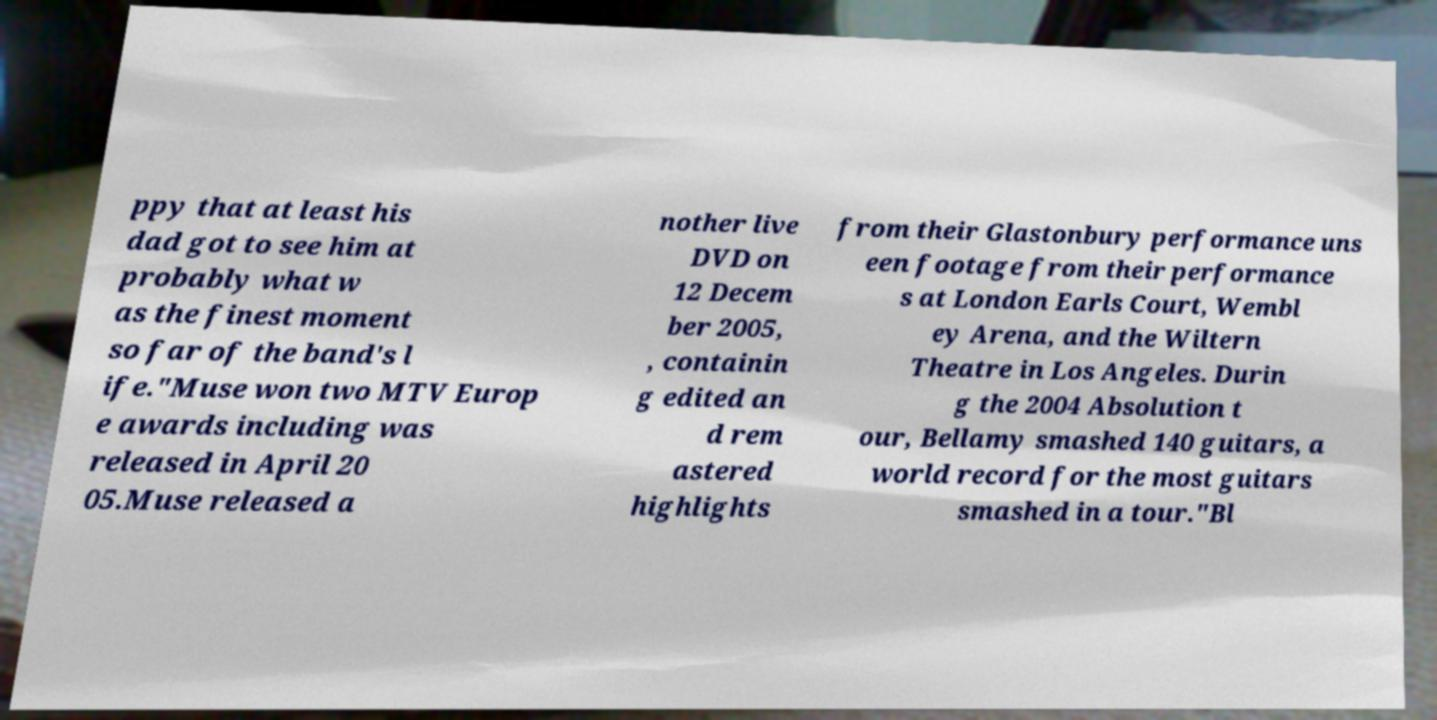What messages or text are displayed in this image? I need them in a readable, typed format. ppy that at least his dad got to see him at probably what w as the finest moment so far of the band's l ife."Muse won two MTV Europ e awards including was released in April 20 05.Muse released a nother live DVD on 12 Decem ber 2005, , containin g edited an d rem astered highlights from their Glastonbury performance uns een footage from their performance s at London Earls Court, Wembl ey Arena, and the Wiltern Theatre in Los Angeles. Durin g the 2004 Absolution t our, Bellamy smashed 140 guitars, a world record for the most guitars smashed in a tour."Bl 